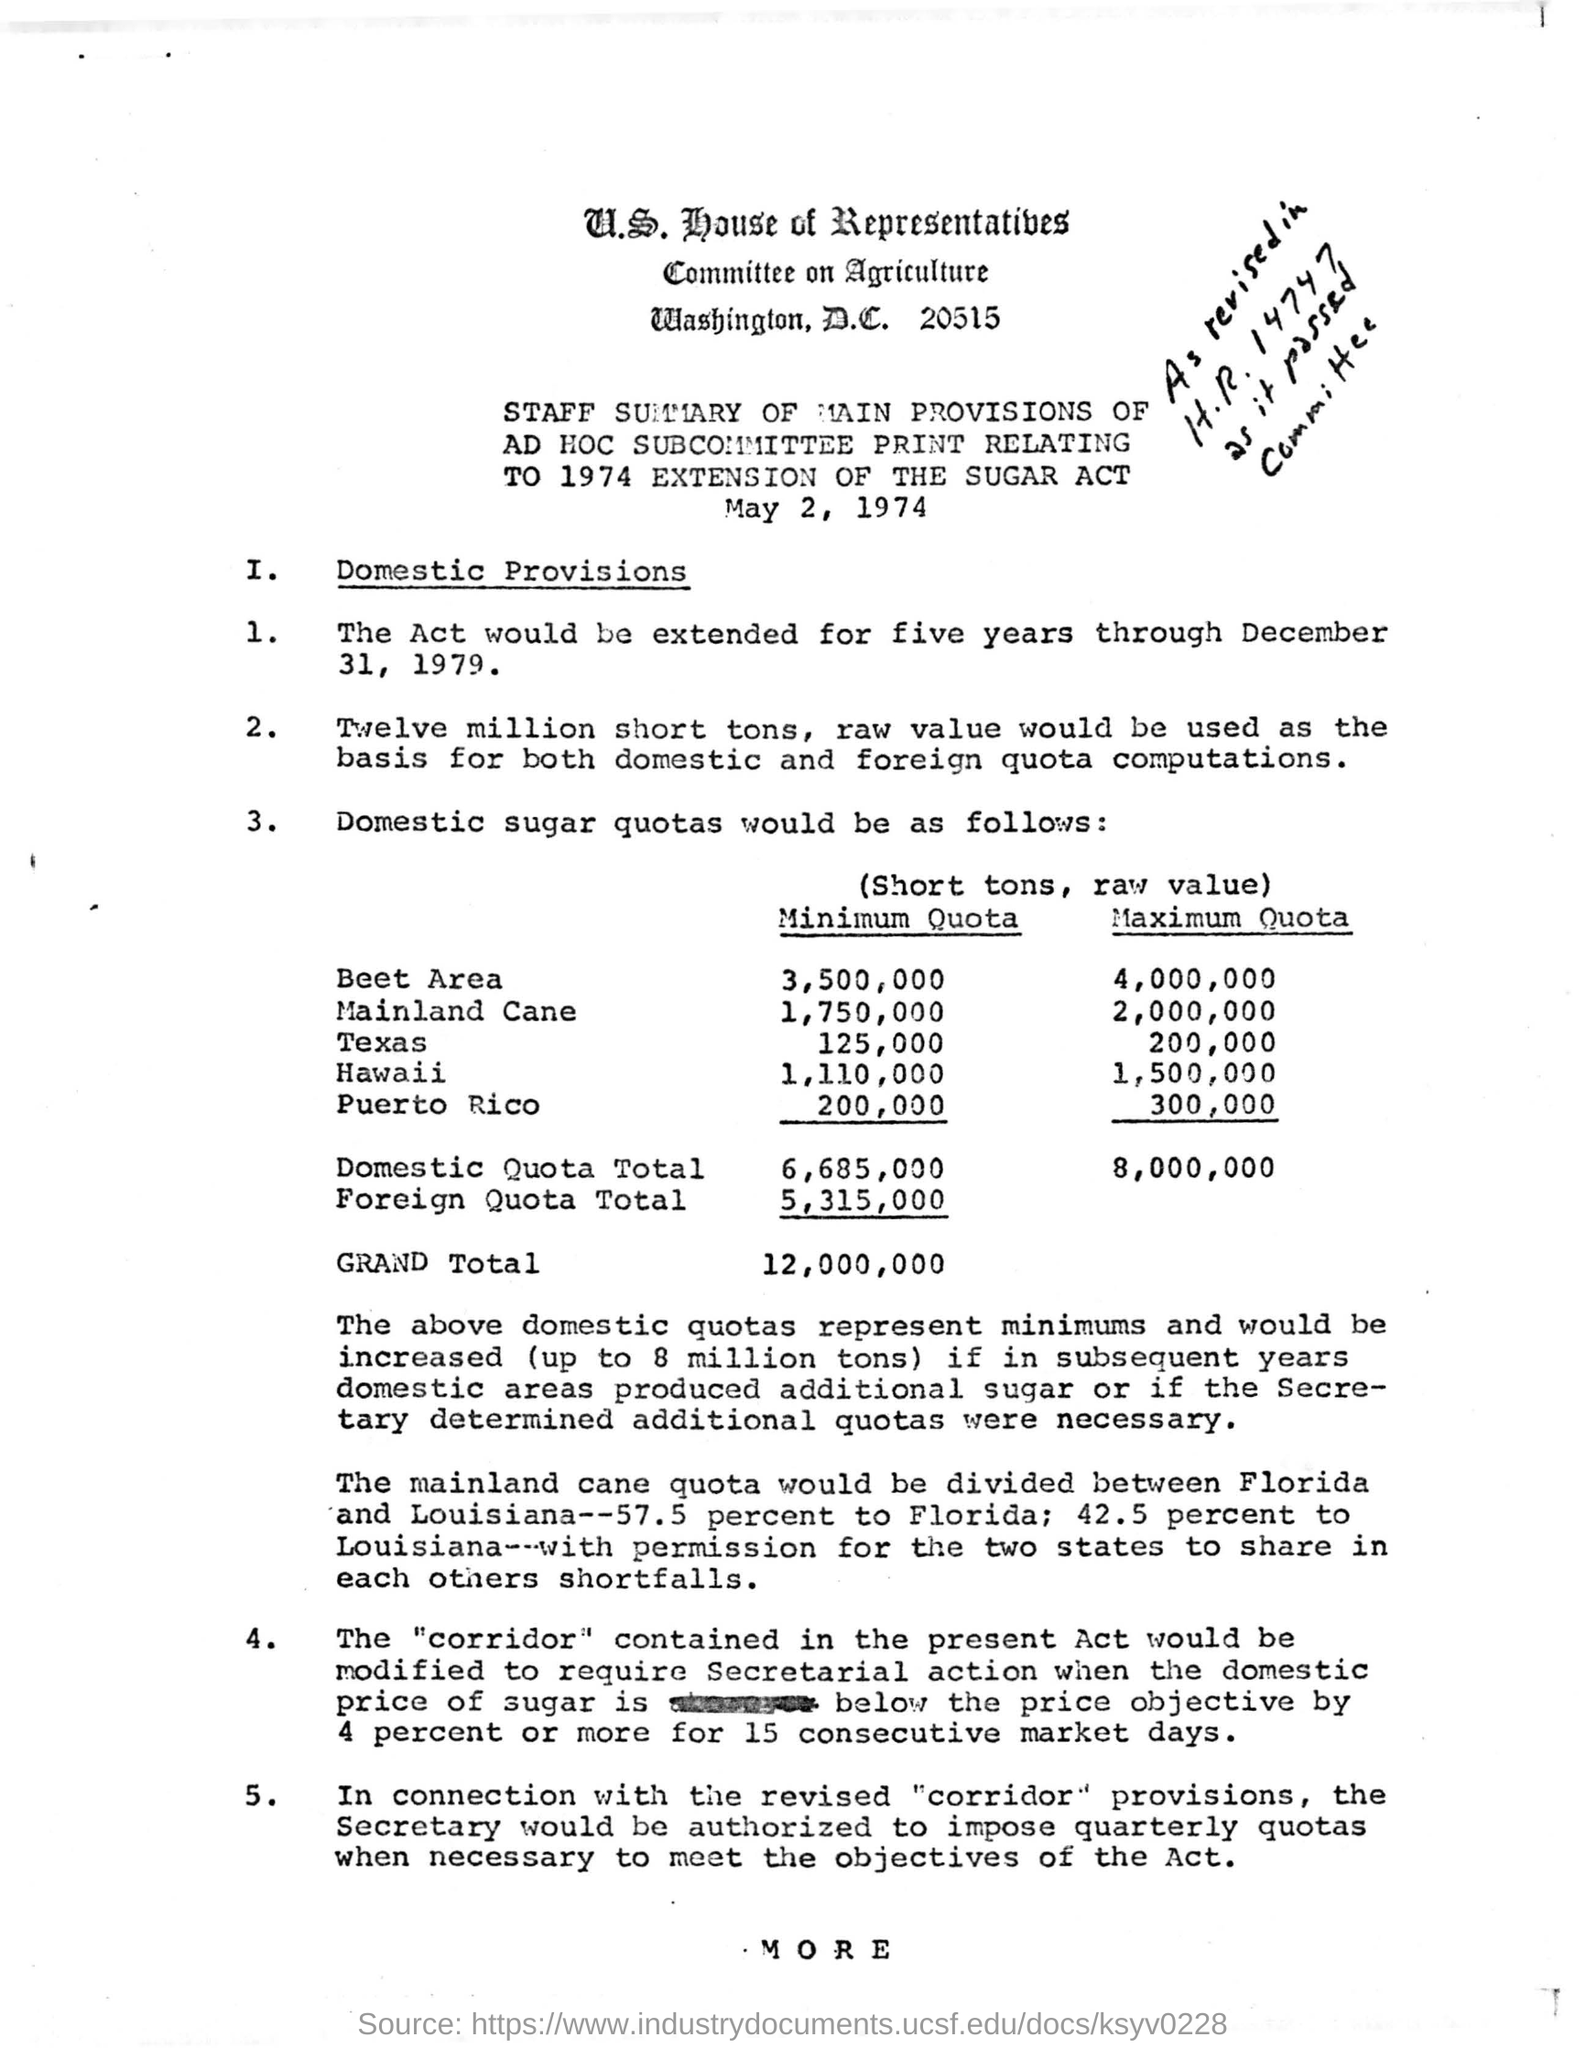Outline some significant characteristics in this image. The maximum quota for Hawaii is 1,500,000. The minimum quota for Texas is 125,000. The minimum quota for the Beet Area is 3,500,000. The maximum quota for Mainland Cane is 2,000,000. 